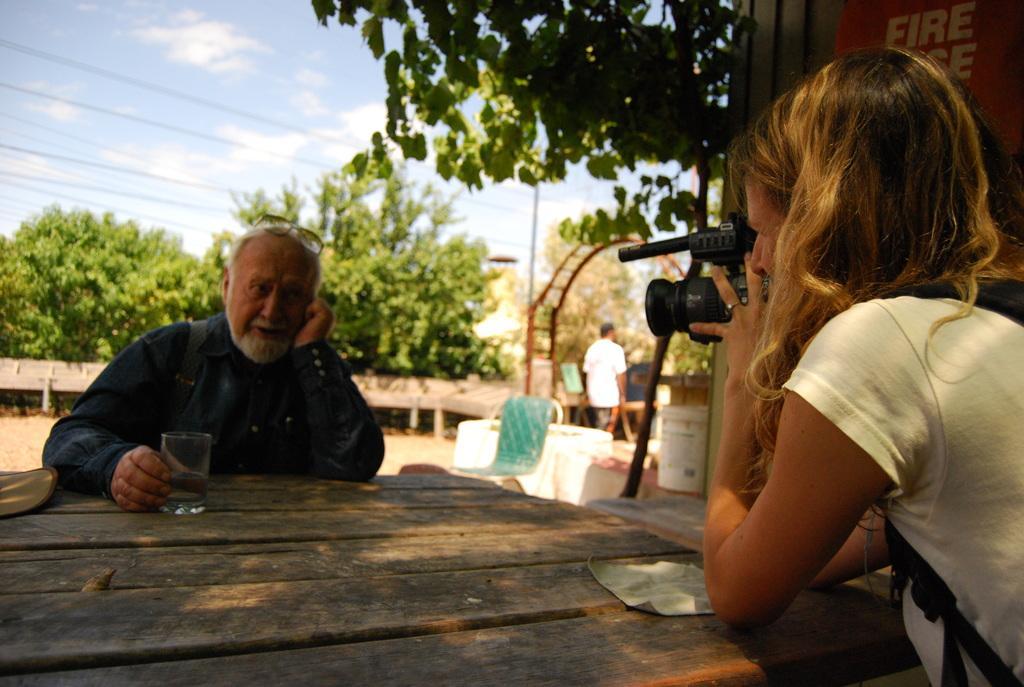Could you give a brief overview of what you see in this image? On the right there is a woman her hair is short ,she is holding a camera. On the left there is an old man he is holding glass. In the back ground a man is walking and there are trees , sky and clouds. 